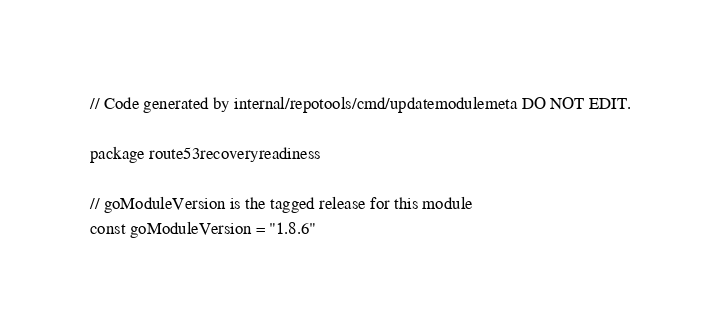Convert code to text. <code><loc_0><loc_0><loc_500><loc_500><_Go_>// Code generated by internal/repotools/cmd/updatemodulemeta DO NOT EDIT.

package route53recoveryreadiness

// goModuleVersion is the tagged release for this module
const goModuleVersion = "1.8.6"
</code> 